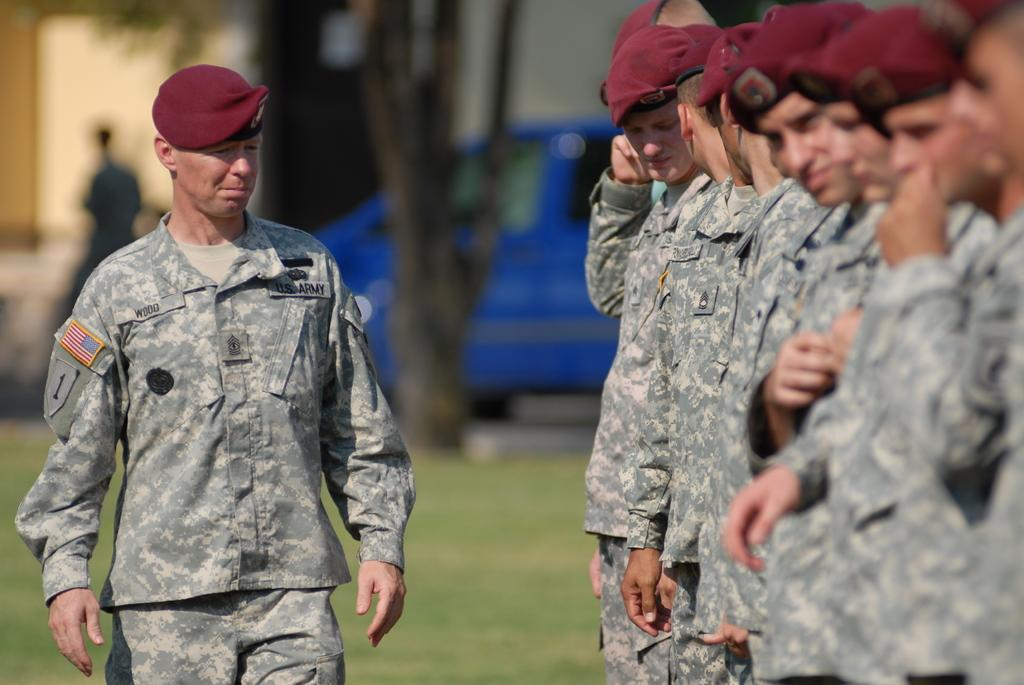Who is present in the image? There are people in the image. What type of clothing are the people wearing? The people are wearing army dress. What type of headgear are the people wearing? The people are wearing caps. What type of terrain is visible in the image? There is grass visible in the image. What type of vehicle is present in the image? There is a vehicle in the image. How would you describe the background of the image? The background of the image is blurred. What flavor of ice cream is the boy eating in the image? There is no boy present in the image, and no ice cream is visible. 